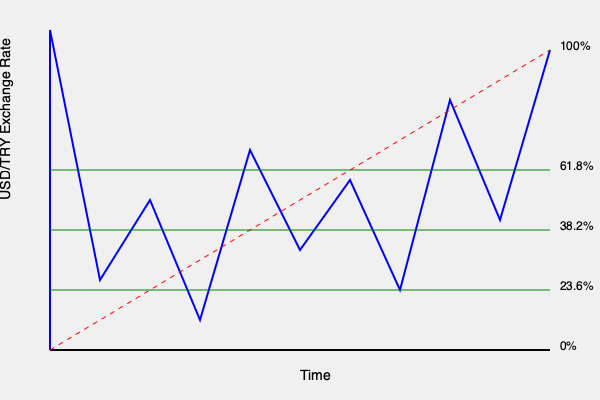Based on the Fibonacci retracement levels shown in the USD/TRY price chart, what is the approximate price level corresponding to the 61.8% retracement, and what does this level typically indicate for emerging market currency traders? To answer this question, we need to follow these steps:

1. Identify the Fibonacci retracement levels:
   The chart shows three main Fibonacci retracement levels: 23.6%, 38.2%, and 61.8%.

2. Locate the 61.8% retracement level:
   This is the third horizontal green line from the bottom of the chart.

3. Estimate the price level:
   The y-axis represents the USD/TRY exchange rate. The 61.8% level appears to be around 17.0.

4. Interpret the significance of the 61.8% level:
   The 61.8% Fibonacci retracement level is considered a key level by many traders, especially in forex markets. For emerging market currencies like the Turkish Lira, this level often indicates:

   a) A potential reversal point in a trend
   b) A strong support or resistance level
   c) An area where traders might consider entering or exiting positions

   In an uptrend, the 61.8% retracement often acts as strong support, while in a downtrend, it can act as strong resistance.

5. Trading implications:
   Experienced forex traders specializing in emerging market currencies might use this level to:
   
   a) Set stop-loss or take-profit orders
   b) Look for confirmation of trend continuation or reversal
   c) Assess the strength of the current trend (if price easily breaks through this level, it might indicate a strong trend)

Understanding and utilizing Fibonacci retracement levels, particularly the 61.8% level, can be crucial for developing trading strategies in volatile emerging market currencies like the Turkish Lira.
Answer: The 61.8% Fibonacci retracement level is approximately at 17.0 USD/TRY, indicating a key support/resistance level and potential reversal point for traders. 